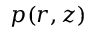Convert formula to latex. <formula><loc_0><loc_0><loc_500><loc_500>p ( r , z )</formula> 